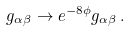<formula> <loc_0><loc_0><loc_500><loc_500>g _ { \alpha \beta } \rightarrow e ^ { - 8 \phi } g _ { \alpha \beta } \, .</formula> 